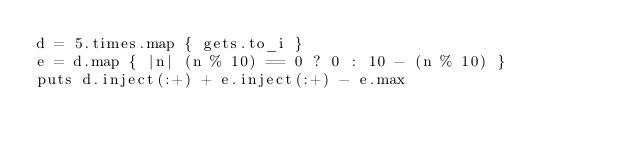Convert code to text. <code><loc_0><loc_0><loc_500><loc_500><_Ruby_>d = 5.times.map { gets.to_i }
e = d.map { |n| (n % 10) == 0 ? 0 : 10 - (n % 10) }
puts d.inject(:+) + e.inject(:+) - e.max</code> 